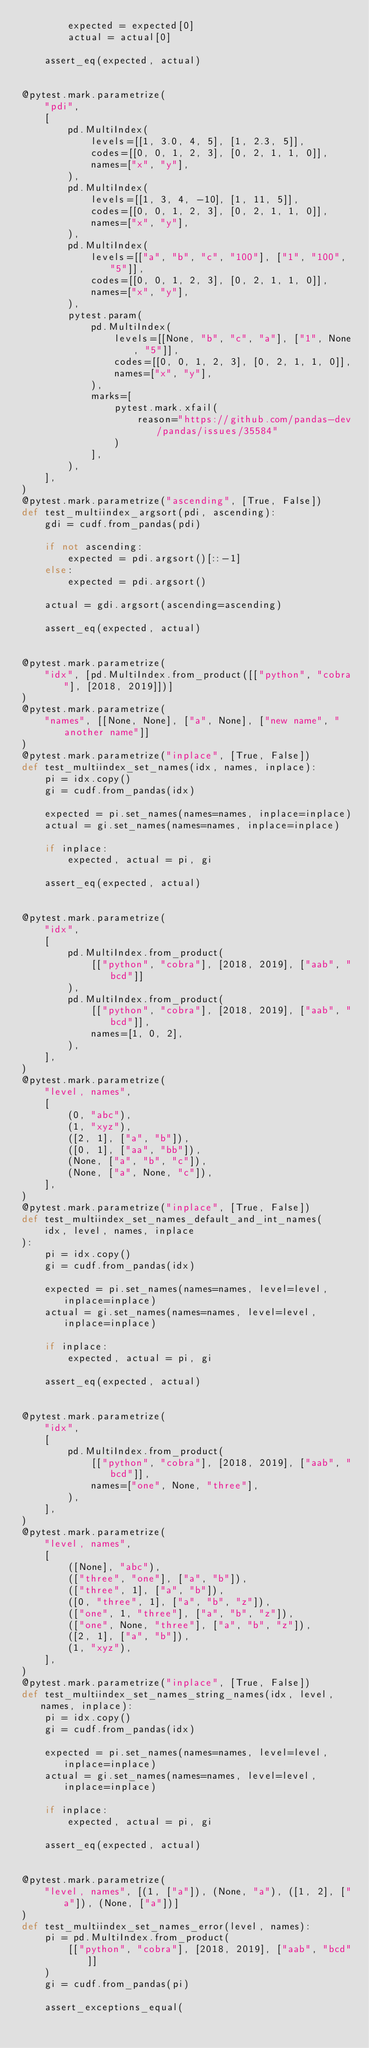<code> <loc_0><loc_0><loc_500><loc_500><_Python_>        expected = expected[0]
        actual = actual[0]

    assert_eq(expected, actual)


@pytest.mark.parametrize(
    "pdi",
    [
        pd.MultiIndex(
            levels=[[1, 3.0, 4, 5], [1, 2.3, 5]],
            codes=[[0, 0, 1, 2, 3], [0, 2, 1, 1, 0]],
            names=["x", "y"],
        ),
        pd.MultiIndex(
            levels=[[1, 3, 4, -10], [1, 11, 5]],
            codes=[[0, 0, 1, 2, 3], [0, 2, 1, 1, 0]],
            names=["x", "y"],
        ),
        pd.MultiIndex(
            levels=[["a", "b", "c", "100"], ["1", "100", "5"]],
            codes=[[0, 0, 1, 2, 3], [0, 2, 1, 1, 0]],
            names=["x", "y"],
        ),
        pytest.param(
            pd.MultiIndex(
                levels=[[None, "b", "c", "a"], ["1", None, "5"]],
                codes=[[0, 0, 1, 2, 3], [0, 2, 1, 1, 0]],
                names=["x", "y"],
            ),
            marks=[
                pytest.mark.xfail(
                    reason="https://github.com/pandas-dev/pandas/issues/35584"
                )
            ],
        ),
    ],
)
@pytest.mark.parametrize("ascending", [True, False])
def test_multiindex_argsort(pdi, ascending):
    gdi = cudf.from_pandas(pdi)

    if not ascending:
        expected = pdi.argsort()[::-1]
    else:
        expected = pdi.argsort()

    actual = gdi.argsort(ascending=ascending)

    assert_eq(expected, actual)


@pytest.mark.parametrize(
    "idx", [pd.MultiIndex.from_product([["python", "cobra"], [2018, 2019]])]
)
@pytest.mark.parametrize(
    "names", [[None, None], ["a", None], ["new name", "another name"]]
)
@pytest.mark.parametrize("inplace", [True, False])
def test_multiindex_set_names(idx, names, inplace):
    pi = idx.copy()
    gi = cudf.from_pandas(idx)

    expected = pi.set_names(names=names, inplace=inplace)
    actual = gi.set_names(names=names, inplace=inplace)

    if inplace:
        expected, actual = pi, gi

    assert_eq(expected, actual)


@pytest.mark.parametrize(
    "idx",
    [
        pd.MultiIndex.from_product(
            [["python", "cobra"], [2018, 2019], ["aab", "bcd"]]
        ),
        pd.MultiIndex.from_product(
            [["python", "cobra"], [2018, 2019], ["aab", "bcd"]],
            names=[1, 0, 2],
        ),
    ],
)
@pytest.mark.parametrize(
    "level, names",
    [
        (0, "abc"),
        (1, "xyz"),
        ([2, 1], ["a", "b"]),
        ([0, 1], ["aa", "bb"]),
        (None, ["a", "b", "c"]),
        (None, ["a", None, "c"]),
    ],
)
@pytest.mark.parametrize("inplace", [True, False])
def test_multiindex_set_names_default_and_int_names(
    idx, level, names, inplace
):
    pi = idx.copy()
    gi = cudf.from_pandas(idx)

    expected = pi.set_names(names=names, level=level, inplace=inplace)
    actual = gi.set_names(names=names, level=level, inplace=inplace)

    if inplace:
        expected, actual = pi, gi

    assert_eq(expected, actual)


@pytest.mark.parametrize(
    "idx",
    [
        pd.MultiIndex.from_product(
            [["python", "cobra"], [2018, 2019], ["aab", "bcd"]],
            names=["one", None, "three"],
        ),
    ],
)
@pytest.mark.parametrize(
    "level, names",
    [
        ([None], "abc"),
        (["three", "one"], ["a", "b"]),
        (["three", 1], ["a", "b"]),
        ([0, "three", 1], ["a", "b", "z"]),
        (["one", 1, "three"], ["a", "b", "z"]),
        (["one", None, "three"], ["a", "b", "z"]),
        ([2, 1], ["a", "b"]),
        (1, "xyz"),
    ],
)
@pytest.mark.parametrize("inplace", [True, False])
def test_multiindex_set_names_string_names(idx, level, names, inplace):
    pi = idx.copy()
    gi = cudf.from_pandas(idx)

    expected = pi.set_names(names=names, level=level, inplace=inplace)
    actual = gi.set_names(names=names, level=level, inplace=inplace)

    if inplace:
        expected, actual = pi, gi

    assert_eq(expected, actual)


@pytest.mark.parametrize(
    "level, names", [(1, ["a"]), (None, "a"), ([1, 2], ["a"]), (None, ["a"])]
)
def test_multiindex_set_names_error(level, names):
    pi = pd.MultiIndex.from_product(
        [["python", "cobra"], [2018, 2019], ["aab", "bcd"]]
    )
    gi = cudf.from_pandas(pi)

    assert_exceptions_equal(</code> 